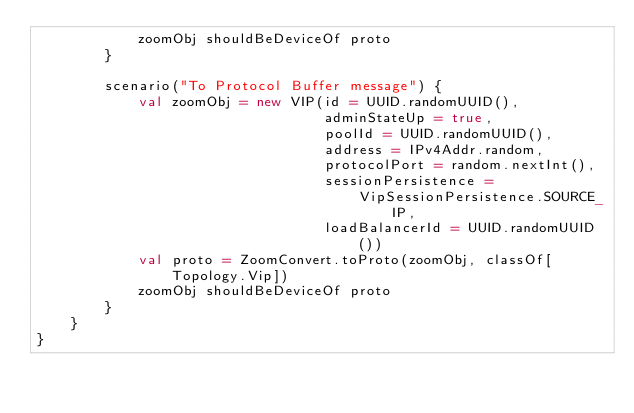<code> <loc_0><loc_0><loc_500><loc_500><_Scala_>            zoomObj shouldBeDeviceOf proto
        }

        scenario("To Protocol Buffer message") {
            val zoomObj = new VIP(id = UUID.randomUUID(),
                                  adminStateUp = true,
                                  poolId = UUID.randomUUID(),
                                  address = IPv4Addr.random,
                                  protocolPort = random.nextInt(),
                                  sessionPersistence =
                                      VipSessionPersistence.SOURCE_IP,
                                  loadBalancerId = UUID.randomUUID())
            val proto = ZoomConvert.toProto(zoomObj, classOf[Topology.Vip])
            zoomObj shouldBeDeviceOf proto
        }
    }
}
</code> 